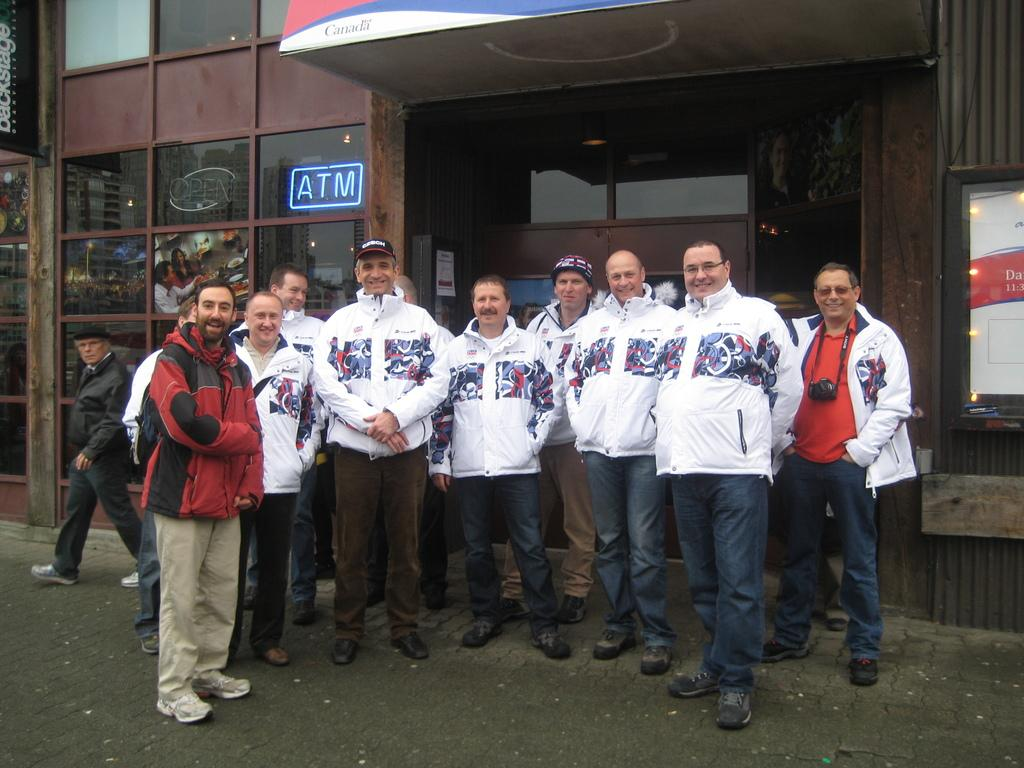<image>
Render a clear and concise summary of the photo. A group of men outside a building with a ATM sign in the window behind them 